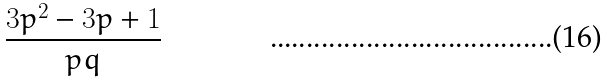<formula> <loc_0><loc_0><loc_500><loc_500>\frac { 3 p ^ { 2 } - 3 p + 1 } { p q }</formula> 